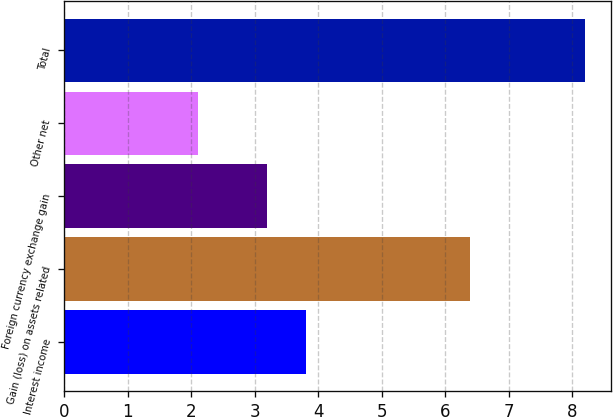Convert chart to OTSL. <chart><loc_0><loc_0><loc_500><loc_500><bar_chart><fcel>Interest income<fcel>Gain (loss) on assets related<fcel>Foreign currency exchange gain<fcel>Other net<fcel>Total<nl><fcel>3.81<fcel>6.4<fcel>3.2<fcel>2.1<fcel>8.2<nl></chart> 